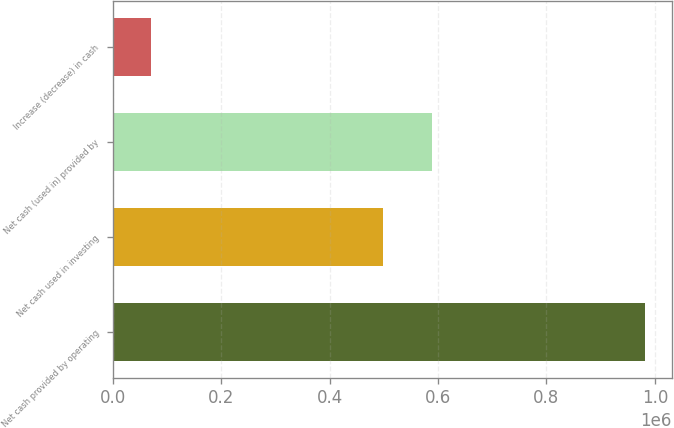<chart> <loc_0><loc_0><loc_500><loc_500><bar_chart><fcel>Net cash provided by operating<fcel>Net cash used in investing<fcel>Net cash (used in) provided by<fcel>Increase (decrease) in cash<nl><fcel>982310<fcel>498324<fcel>589552<fcel>70030<nl></chart> 